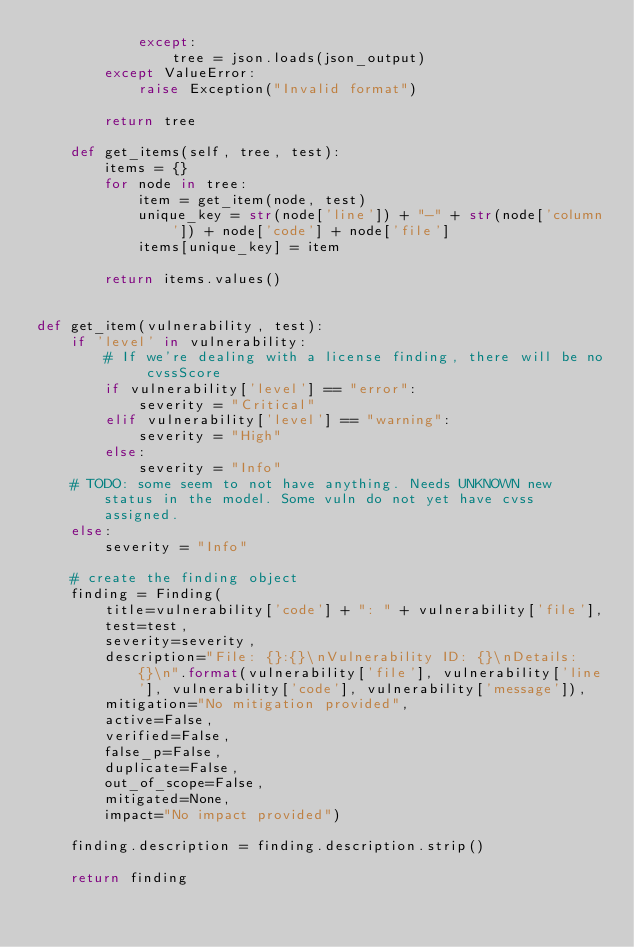<code> <loc_0><loc_0><loc_500><loc_500><_Python_>            except:
                tree = json.loads(json_output)
        except ValueError:
            raise Exception("Invalid format")

        return tree

    def get_items(self, tree, test):
        items = {}
        for node in tree:
            item = get_item(node, test)
            unique_key = str(node['line']) + "-" + str(node['column']) + node['code'] + node['file']
            items[unique_key] = item

        return items.values()


def get_item(vulnerability, test):
    if 'level' in vulnerability:
        # If we're dealing with a license finding, there will be no cvssScore
        if vulnerability['level'] == "error":
            severity = "Critical"
        elif vulnerability['level'] == "warning":
            severity = "High"
        else:
            severity = "Info"
    # TODO: some seem to not have anything. Needs UNKNOWN new status in the model. Some vuln do not yet have cvss assigned.
    else:
        severity = "Info"

    # create the finding object
    finding = Finding(
        title=vulnerability['code'] + ": " + vulnerability['file'],
        test=test,
        severity=severity,
        description="File: {}:{}\nVulnerability ID: {}\nDetails: {}\n".format(vulnerability['file'], vulnerability['line'], vulnerability['code'], vulnerability['message']),
        mitigation="No mitigation provided",
        active=False,
        verified=False,
        false_p=False,
        duplicate=False,
        out_of_scope=False,
        mitigated=None,
        impact="No impact provided")

    finding.description = finding.description.strip()

    return finding
</code> 